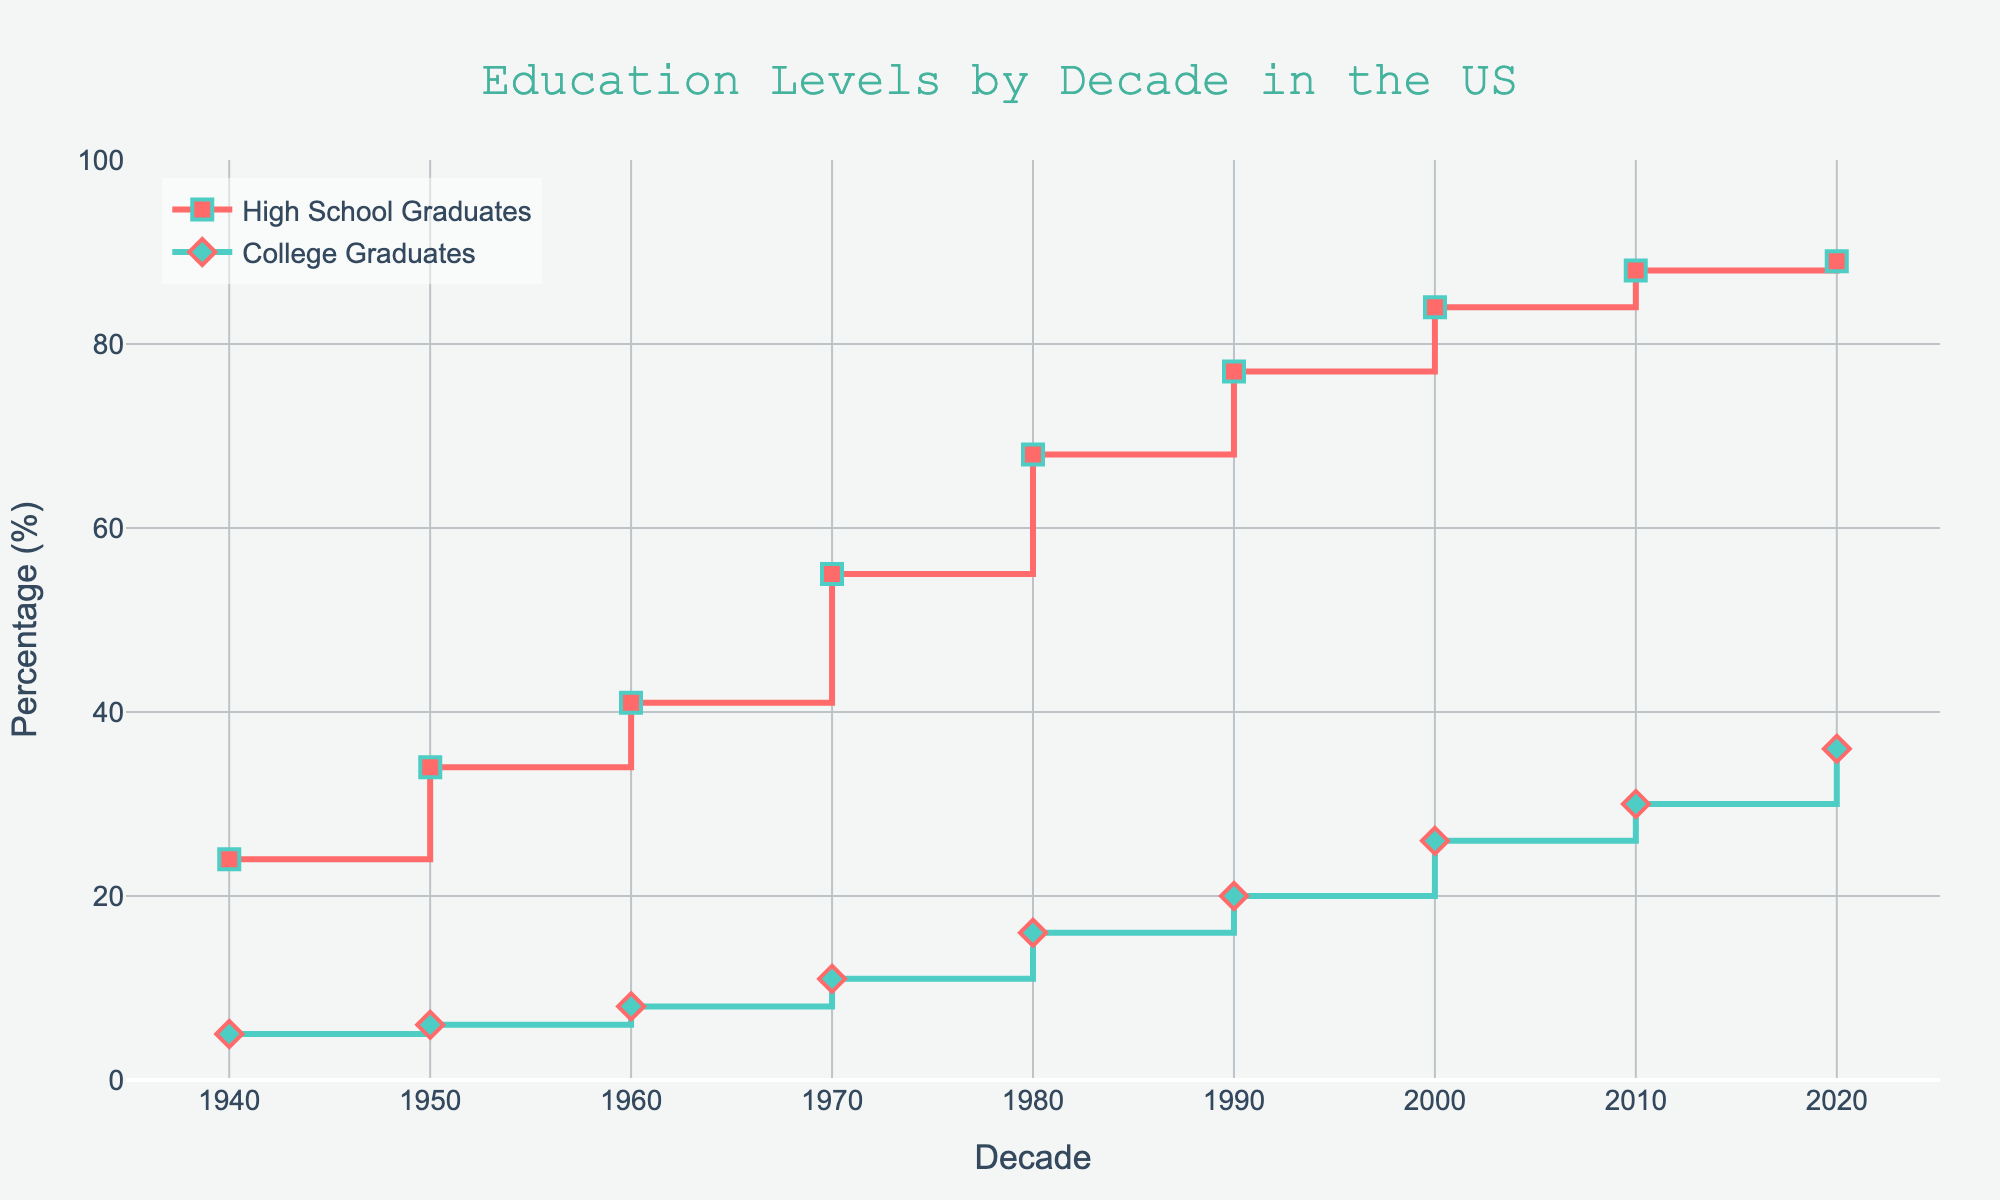how many decades are represented on the x-axis? The x-axis shows years marked in decades. Count the points visible on the axis from 1940 to 2020.
Answer: 9 what color is the line representing high school graduates? Observe the line plot corresponding to high school graduates, which is visually distinct in color.
Answer: Red what is the highest percentage of college graduates and in which decade does it occur? Look at the data points for college graduates (%) on the y-axis and find the peak point. Then check the x-axis for the corresponding decade.
Answer: 36% in 2020 how many percentage points did the high school graduation rate increase from 1940 to 1980? Identify the data points for 1940 and 1980 for high school graduates on the y-axis. Subtract the 1940 value from the 1980 value to determine the increase.
Answer: 44 points in which decade did the percentage of college graduates first exceed 20%? Review the y-axis values for college graduates and find the first decade where the percentage surpasses 20%.
Answer: 1990 when was the smallest gap between high school and college graduation rates, and what was the gap? Calculate the difference between the lines representing high school and college graduates for each decade. Identify the decade with the smallest difference and the value of that difference.
Answer: 1940, 19% gap how much did the percentage of high school graduates increase from 1950 to 2010? Find the high school graduation percentages for 1950 and 2010, then subtract the 1950 value from the 2010 value.
Answer: 54 points which type of graduates saw the largest increase from the 2000s to 2020? Compare the increase in values for high school graduates and college graduates between 2000 and 2020. Determine which increase is larger.
Answer: College graduates what was the percentage of high school graduates in the decade when college graduates reached 11%? Identify the decade where college graduates are at 11% and check the corresponding value for high school graduates.
Answer: 1970, 55% what is the average percentage of high school graduates across all decades shown? Add the percentages of high school graduates for each decade and divide by the total number of decades (9).
Answer: Approximately 62.2% 